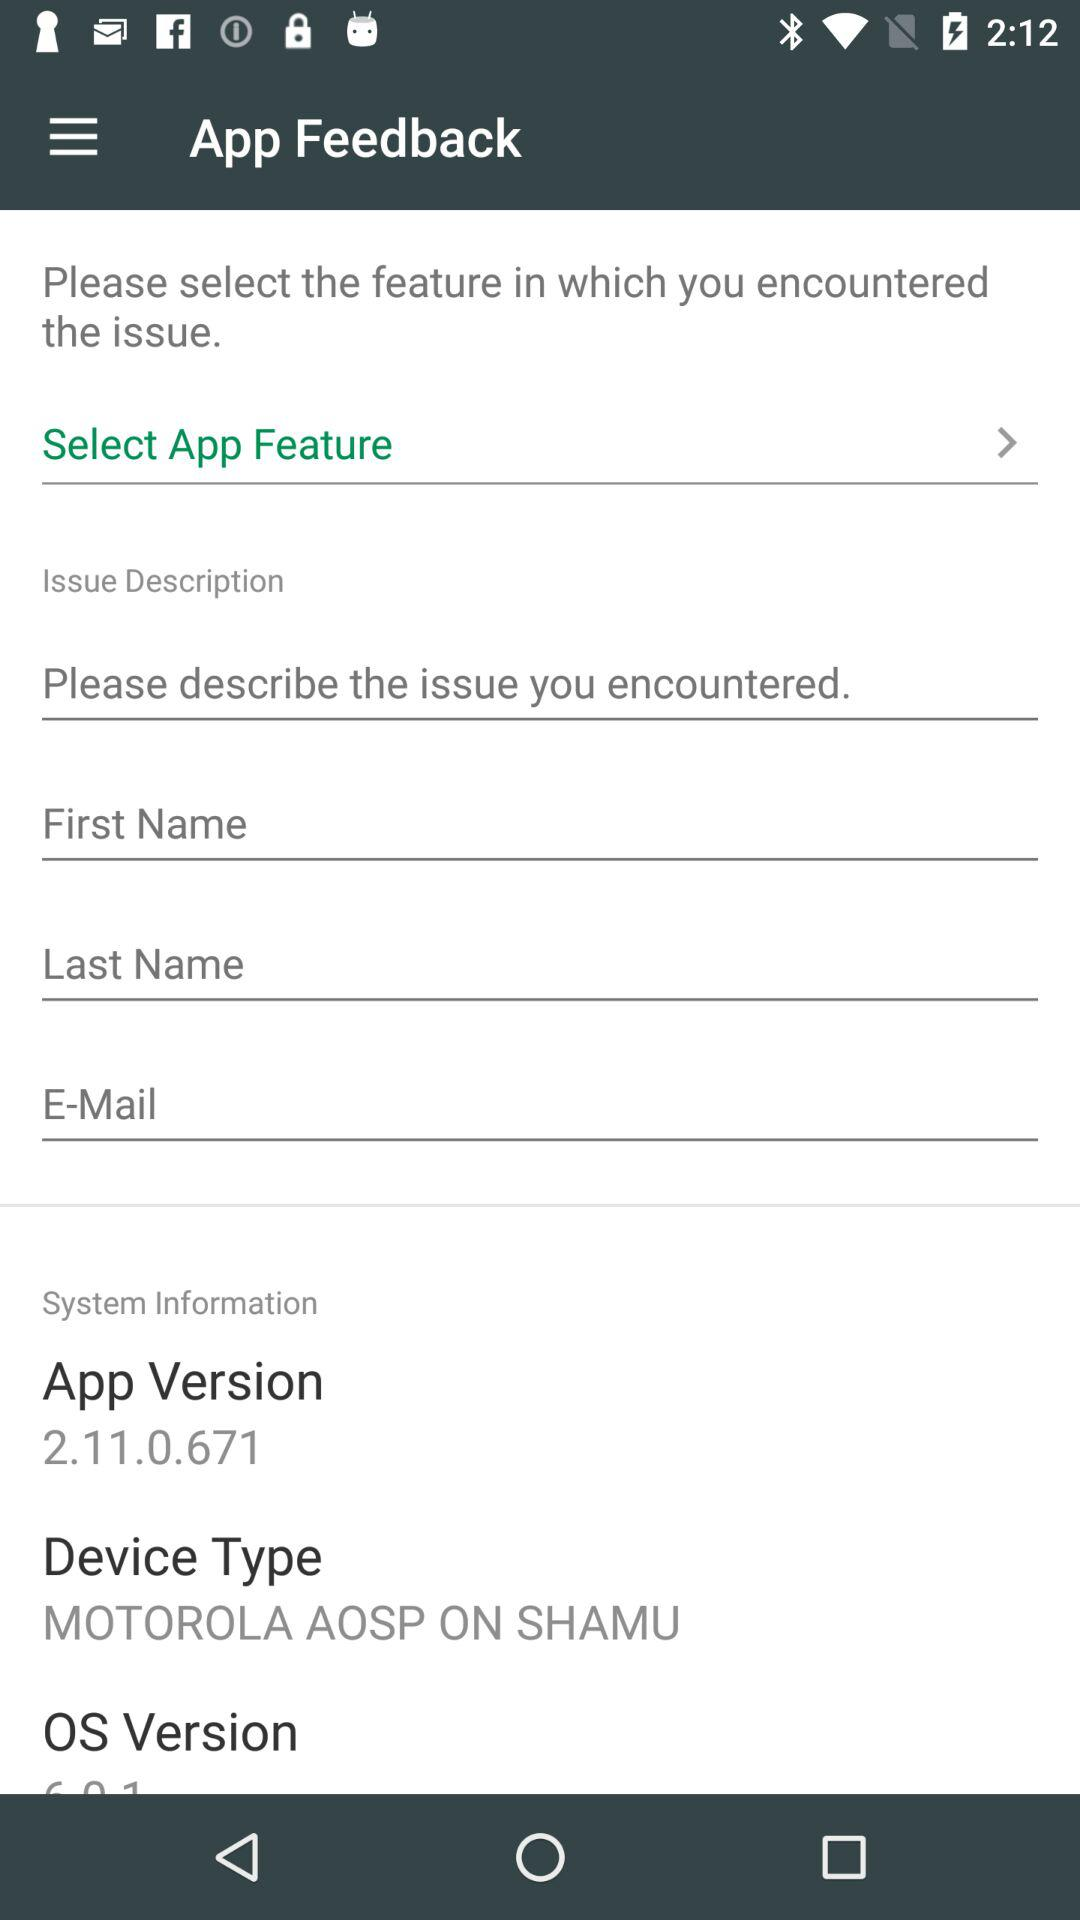What is the name of the application?
When the provided information is insufficient, respond with <no answer>. <no answer> 